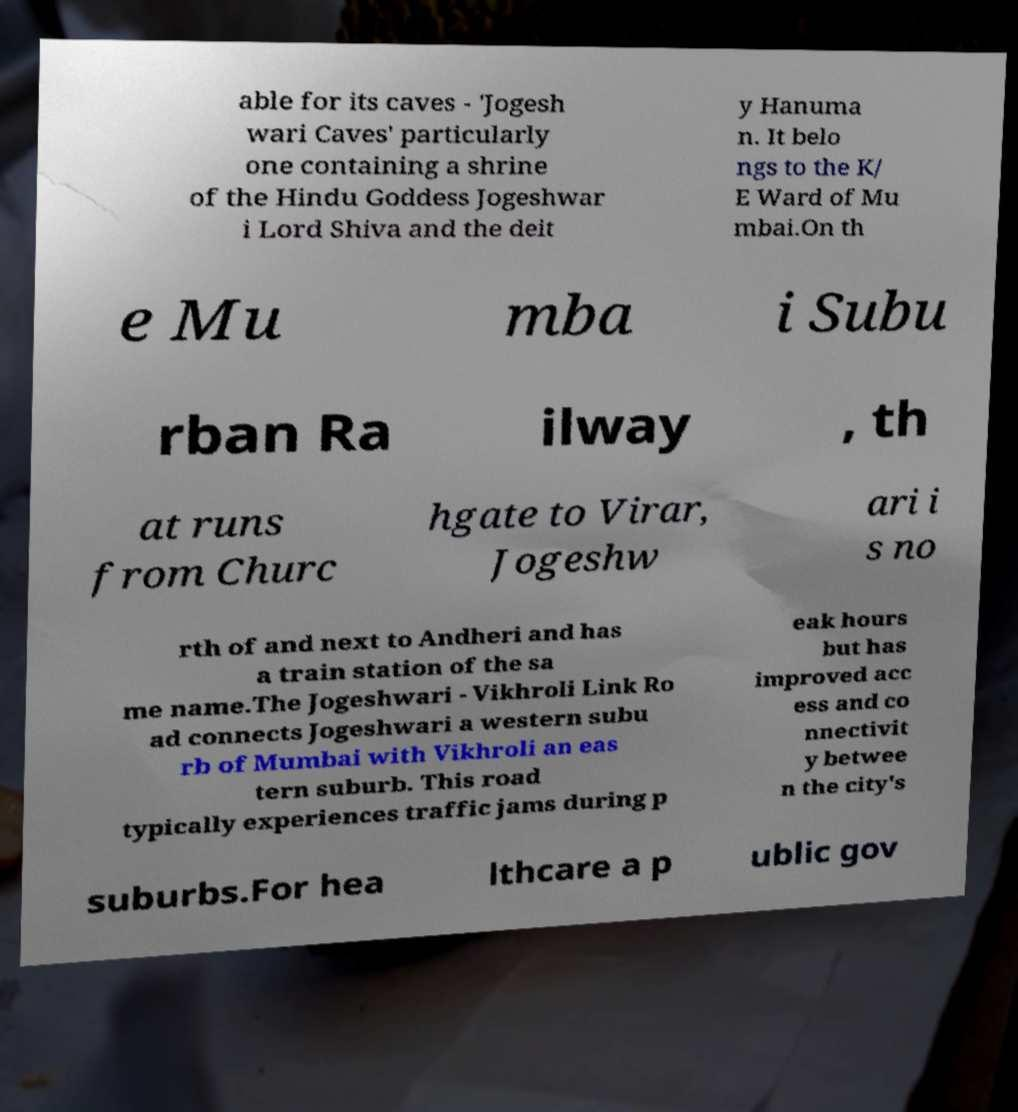Could you extract and type out the text from this image? able for its caves - 'Jogesh wari Caves' particularly one containing a shrine of the Hindu Goddess Jogeshwar i Lord Shiva and the deit y Hanuma n. It belo ngs to the K/ E Ward of Mu mbai.On th e Mu mba i Subu rban Ra ilway , th at runs from Churc hgate to Virar, Jogeshw ari i s no rth of and next to Andheri and has a train station of the sa me name.The Jogeshwari - Vikhroli Link Ro ad connects Jogeshwari a western subu rb of Mumbai with Vikhroli an eas tern suburb. This road typically experiences traffic jams during p eak hours but has improved acc ess and co nnectivit y betwee n the city's suburbs.For hea lthcare a p ublic gov 